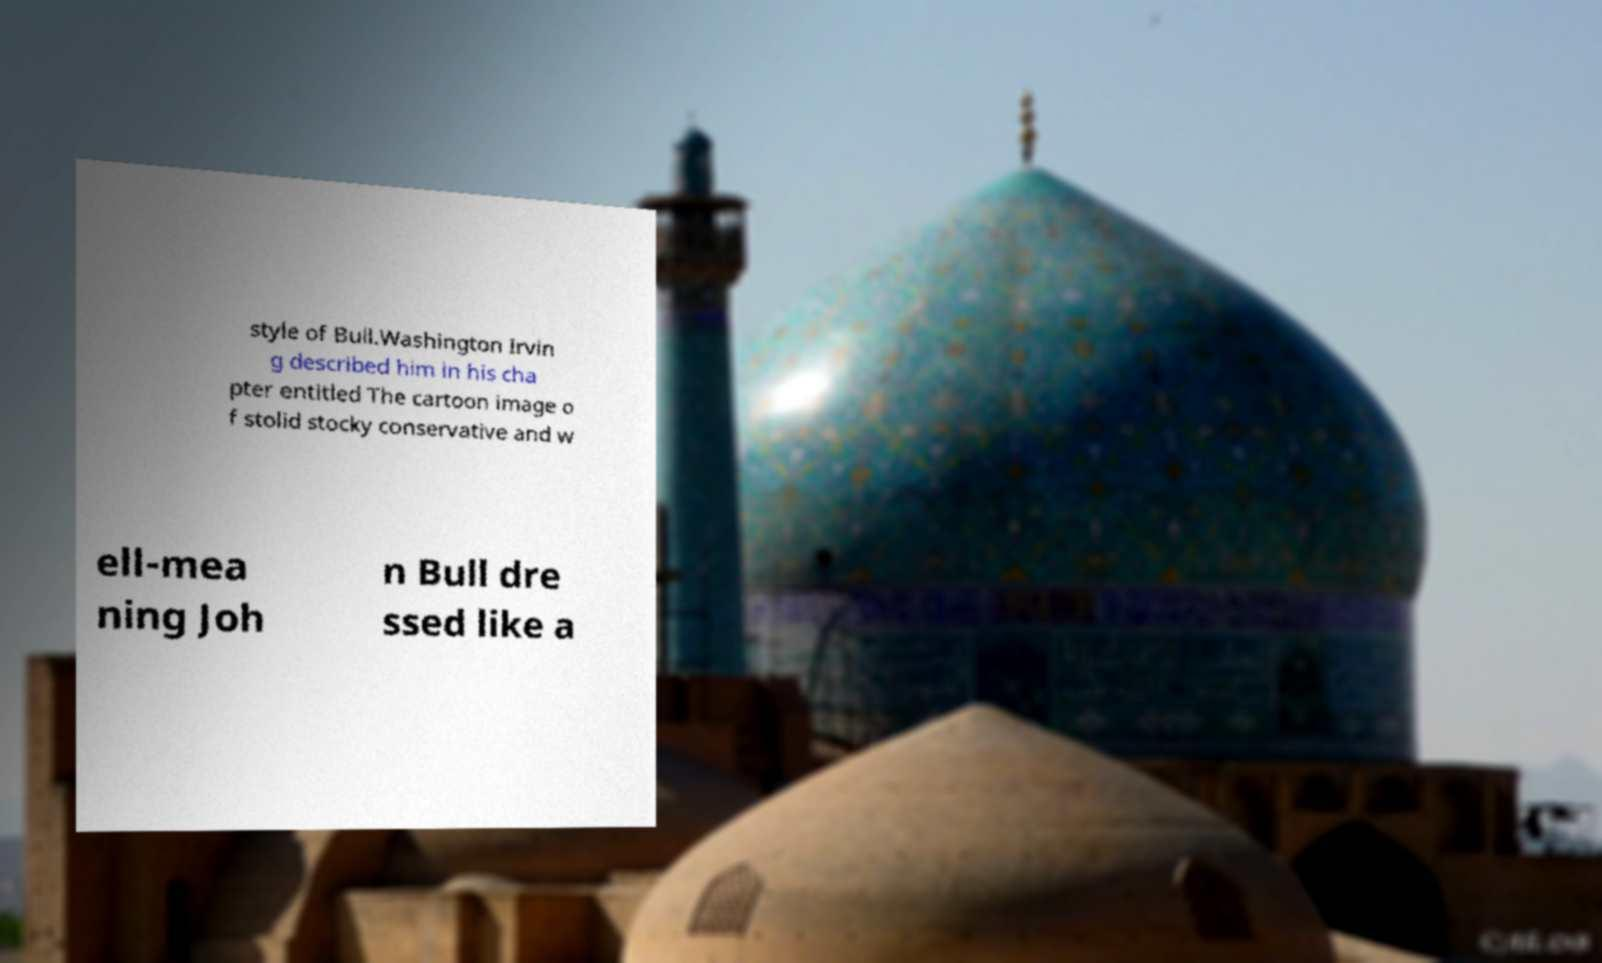I need the written content from this picture converted into text. Can you do that? style of Bull.Washington Irvin g described him in his cha pter entitled The cartoon image o f stolid stocky conservative and w ell-mea ning Joh n Bull dre ssed like a 